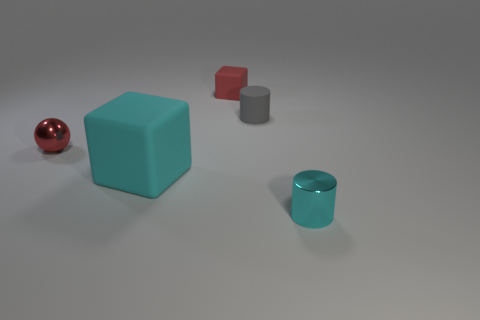What is the color of the matte object that is in front of the tiny shiny object that is to the left of the rubber cube that is in front of the tiny red rubber cube?
Your response must be concise. Cyan. There is a red shiny ball; does it have the same size as the metallic object that is to the right of the gray rubber cylinder?
Give a very brief answer. Yes. What number of things are either small metallic cylinders or rubber blocks?
Provide a succinct answer. 3. Is there a gray cylinder made of the same material as the tiny ball?
Your answer should be compact. No. There is a cylinder that is the same color as the big block; what size is it?
Your answer should be very brief. Small. What is the color of the tiny metallic thing that is on the left side of the small object that is behind the gray thing?
Ensure brevity in your answer.  Red. Do the red rubber object and the gray object have the same size?
Make the answer very short. Yes. How many balls are red matte objects or cyan metallic objects?
Provide a succinct answer. 0. How many large cyan matte things are in front of the small red metallic sphere that is behind the small cyan metallic thing?
Keep it short and to the point. 1. Do the red shiny thing and the gray object have the same shape?
Your answer should be compact. No. 